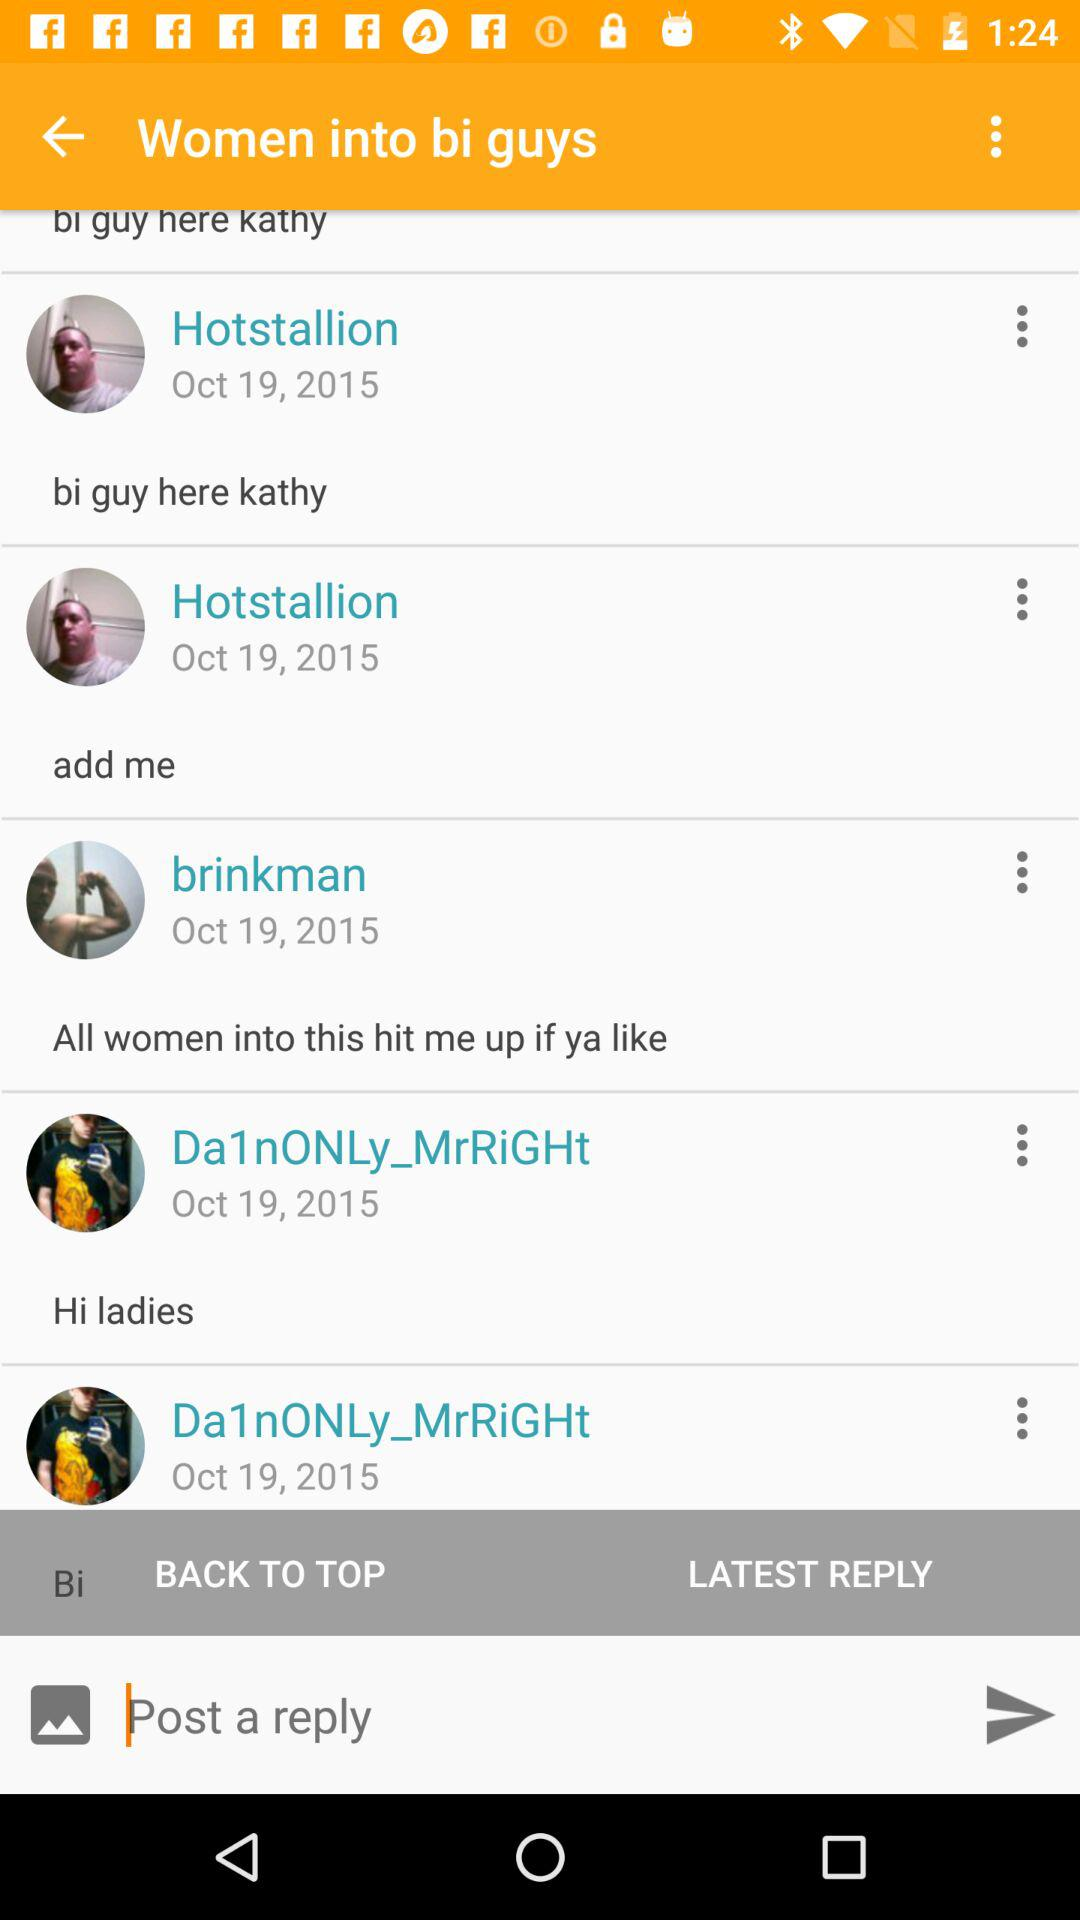What is the date of "brinkman"? The date is October 19, 2015. 